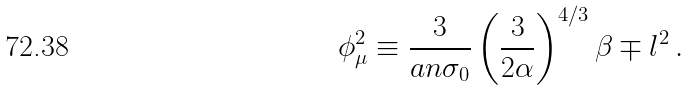Convert formula to latex. <formula><loc_0><loc_0><loc_500><loc_500>\phi _ { \mu } ^ { 2 } \equiv \frac { 3 } { a n \sigma _ { 0 } } \left ( \frac { 3 } { 2 \alpha } \right ) ^ { 4 / 3 } \beta \mp l ^ { 2 } \, .</formula> 